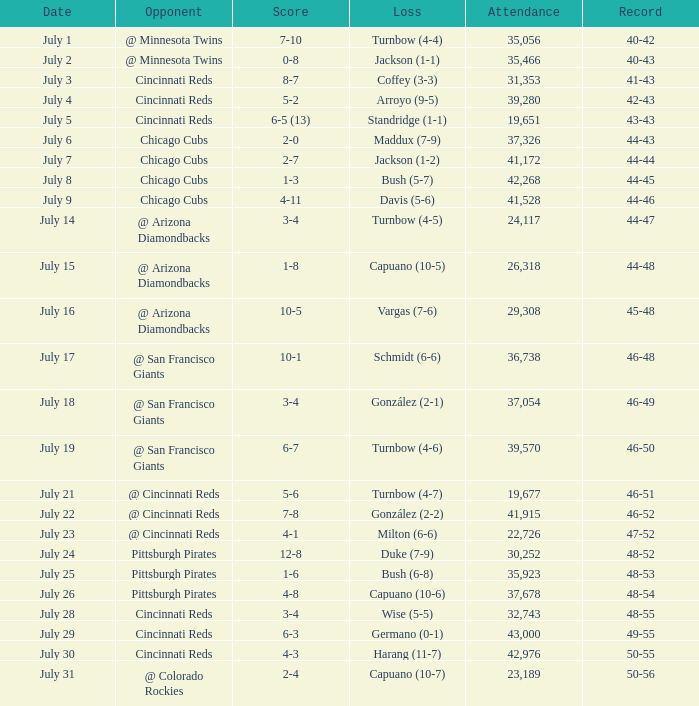What was the record for the game with a 7-10 score? 40-42. 